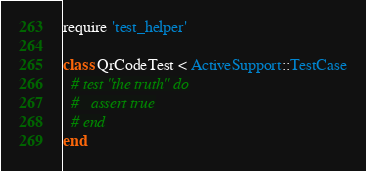Convert code to text. <code><loc_0><loc_0><loc_500><loc_500><_Ruby_>require 'test_helper'

class QrCodeTest < ActiveSupport::TestCase
  # test "the truth" do
  #   assert true
  # end
end
</code> 